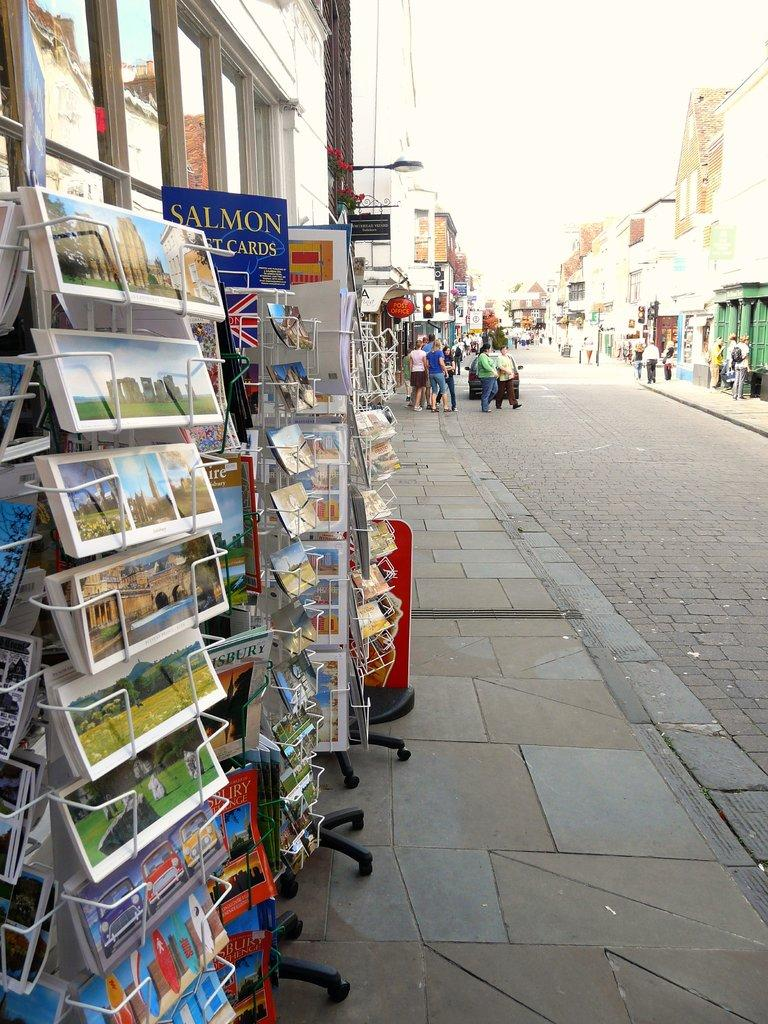<image>
Create a compact narrative representing the image presented. A blue sign on a card stand says Salmon gift cards. 